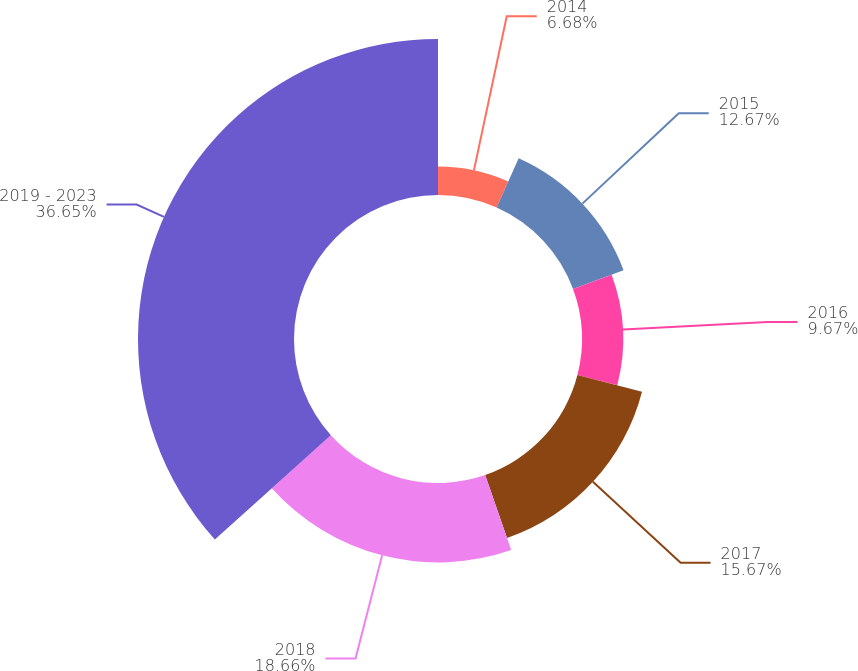Convert chart to OTSL. <chart><loc_0><loc_0><loc_500><loc_500><pie_chart><fcel>2014<fcel>2015<fcel>2016<fcel>2017<fcel>2018<fcel>2019 - 2023<nl><fcel>6.68%<fcel>12.67%<fcel>9.67%<fcel>15.67%<fcel>18.66%<fcel>36.65%<nl></chart> 